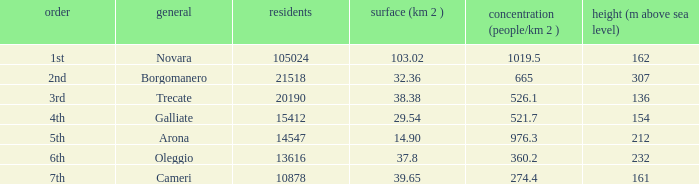Which common has an area (km2) of 103.02? Novara. 